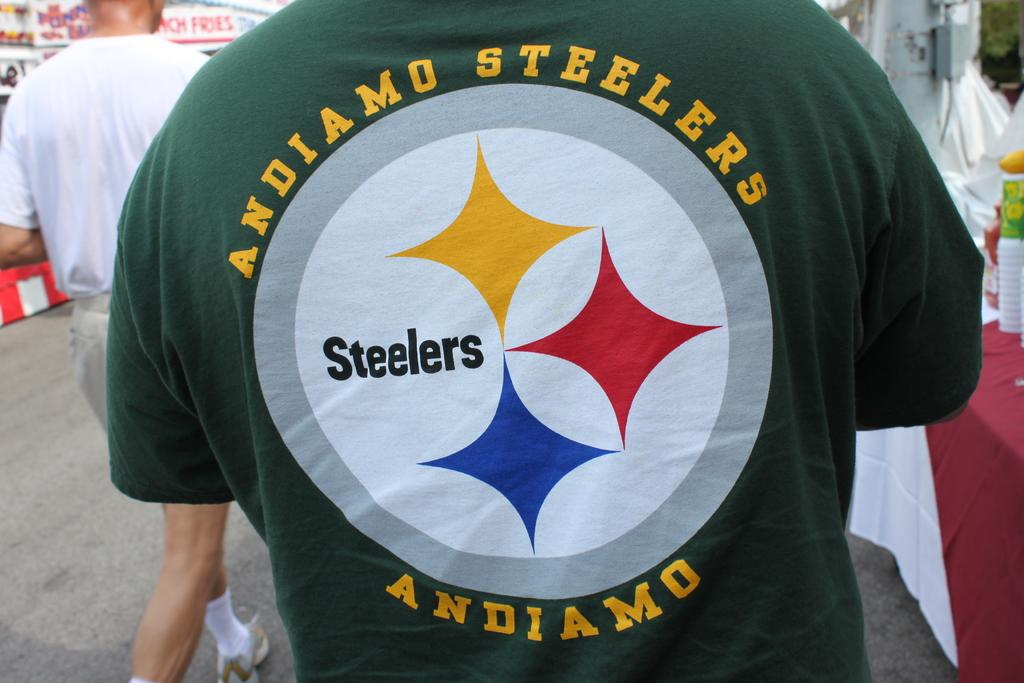Provide a one-sentence caption for the provided image. A man's t-shirt shows support for the Steelers and urges them on in Italian. 